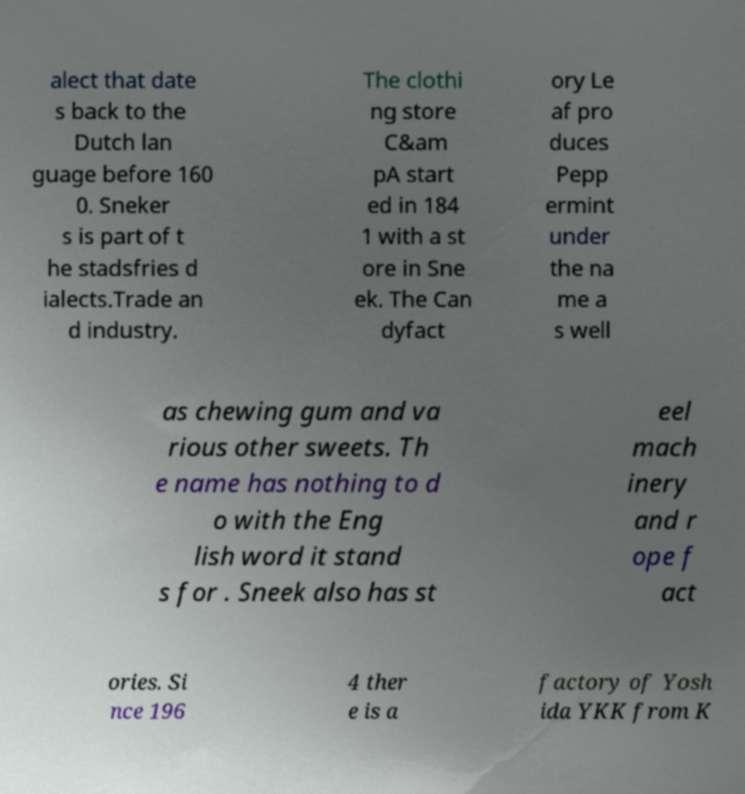Please identify and transcribe the text found in this image. alect that date s back to the Dutch lan guage before 160 0. Sneker s is part of t he stadsfries d ialects.Trade an d industry. The clothi ng store C&am pA start ed in 184 1 with a st ore in Sne ek. The Can dyfact ory Le af pro duces Pepp ermint under the na me a s well as chewing gum and va rious other sweets. Th e name has nothing to d o with the Eng lish word it stand s for . Sneek also has st eel mach inery and r ope f act ories. Si nce 196 4 ther e is a factory of Yosh ida YKK from K 